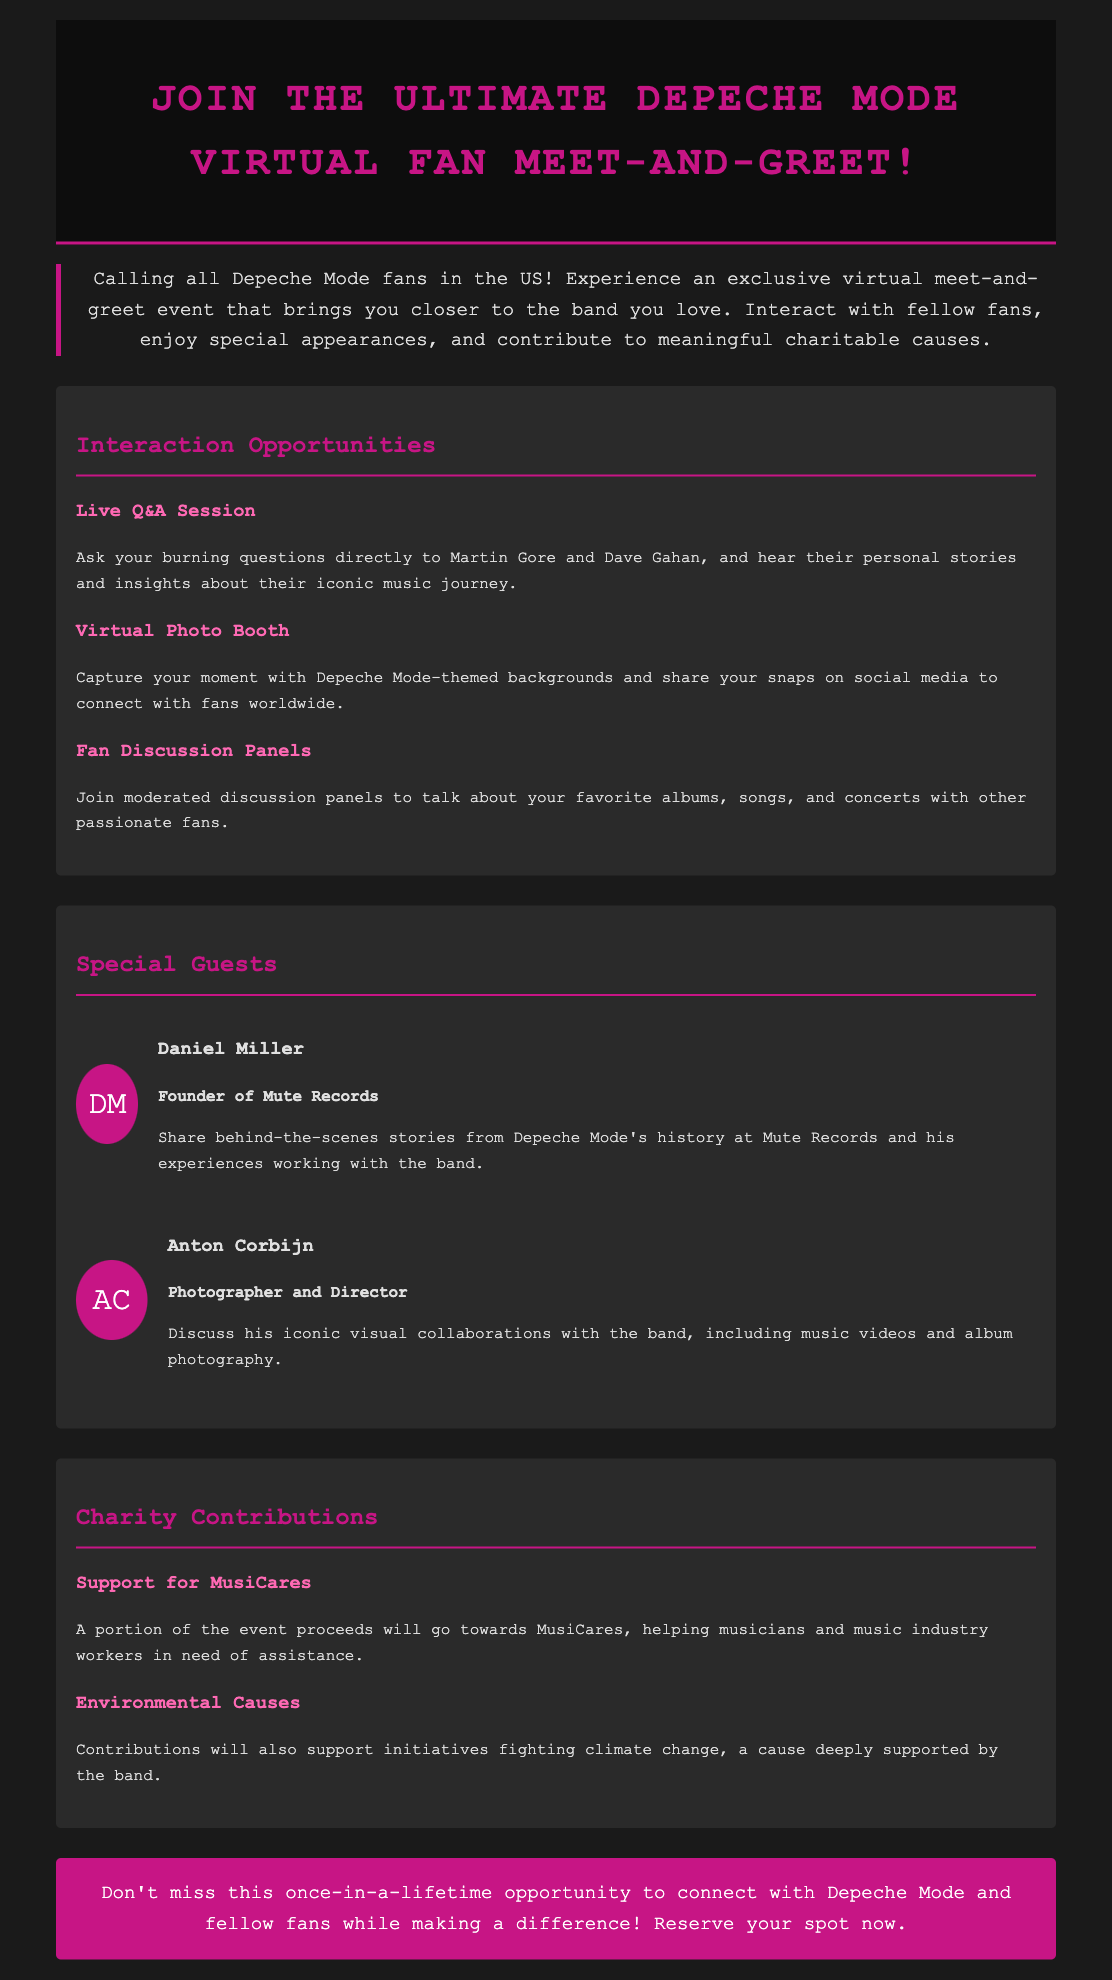What is the title of the event? The title of the event is found prominently at the top of the document, which states "Join the Ultimate Depeche Mode Virtual Fan Meet-and-Greet!"
Answer: Ultimate Depeche Mode Virtual Fan Meet-and-Greet Who are the special guests? The document lists two special guests, providing their names and roles.
Answer: Daniel Miller and Anton Corbijn What charitable cause does the event support? The document specifically mentions that a portion of the proceeds goes to MusiCares.
Answer: MusiCares How many interaction opportunities are highlighted? The document provides a section detailing three specific interaction opportunities available at the event.
Answer: Three What is the main color used for the call-to-action button? The document describes the color of the call-to-action button, which stands out visually.
Answer: Pink Who can participate in this event? The introductory paragraph specifies the target audience for the event.
Answer: Depeche Mode fans in the US What type of session is included for fan interaction? The document mentions a particular type of session designed for fans to engage directly with band members.
Answer: Live Q&A Session What portion of the event proceeds supports environmental causes? The document states contributions will support initiatives fighting a specific issue.
Answer: Climate change 